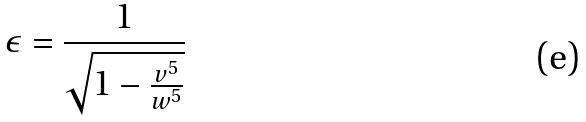Convert formula to latex. <formula><loc_0><loc_0><loc_500><loc_500>\epsilon = \frac { 1 } { \sqrt { 1 - \frac { v ^ { 5 } } { w ^ { 5 } } } }</formula> 